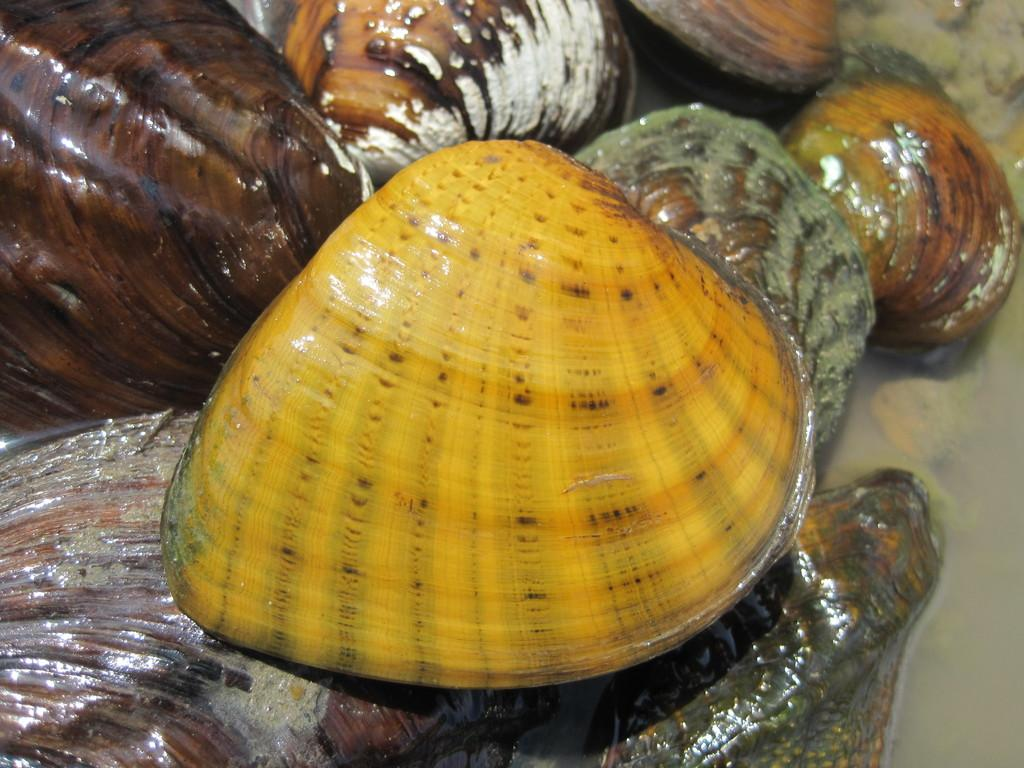What is in the water in the image? There are seashells in the water. What can be observed about the seashells in the image? The seashells are of different colors. Can you name any specific colors of the seashells? Yes, the colors mentioned are yellow and brown. How many sheep can be seen grazing in the image? There are no sheep present in the image; it features seashells in the water. What type of grape is being eaten by the boy in the image? There is no boy or grape present in the image. 